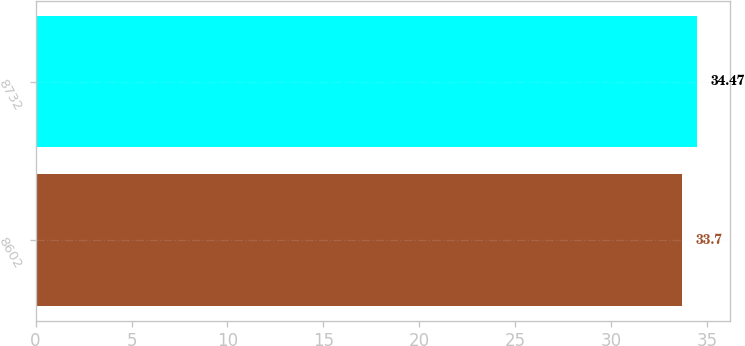Convert chart. <chart><loc_0><loc_0><loc_500><loc_500><bar_chart><fcel>8602<fcel>8732<nl><fcel>33.7<fcel>34.47<nl></chart> 